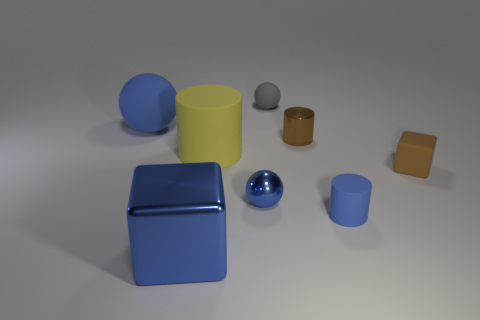There is a tiny object that is both in front of the big blue sphere and on the left side of the metallic cylinder; what is its shape?
Your answer should be very brief. Sphere. There is a block that is the same color as the small metallic sphere; what is its material?
Ensure brevity in your answer.  Metal. What number of cubes are matte objects or small blue matte things?
Your answer should be compact. 1. There is a cylinder that is the same color as the small shiny sphere; what size is it?
Keep it short and to the point. Small. Is the number of metal objects in front of the large yellow object less than the number of cylinders?
Offer a terse response. Yes. There is a metallic object that is both in front of the brown cube and behind the blue metallic cube; what is its color?
Your response must be concise. Blue. How many other things are there of the same shape as the tiny brown metallic thing?
Provide a succinct answer. 2. Are there fewer blue metallic cubes in front of the big rubber cylinder than large things that are behind the brown block?
Offer a terse response. Yes. Do the large blue sphere and the brown block right of the yellow rubber thing have the same material?
Make the answer very short. Yes. Is the number of metallic spheres greater than the number of tiny green metallic blocks?
Your answer should be compact. Yes. 